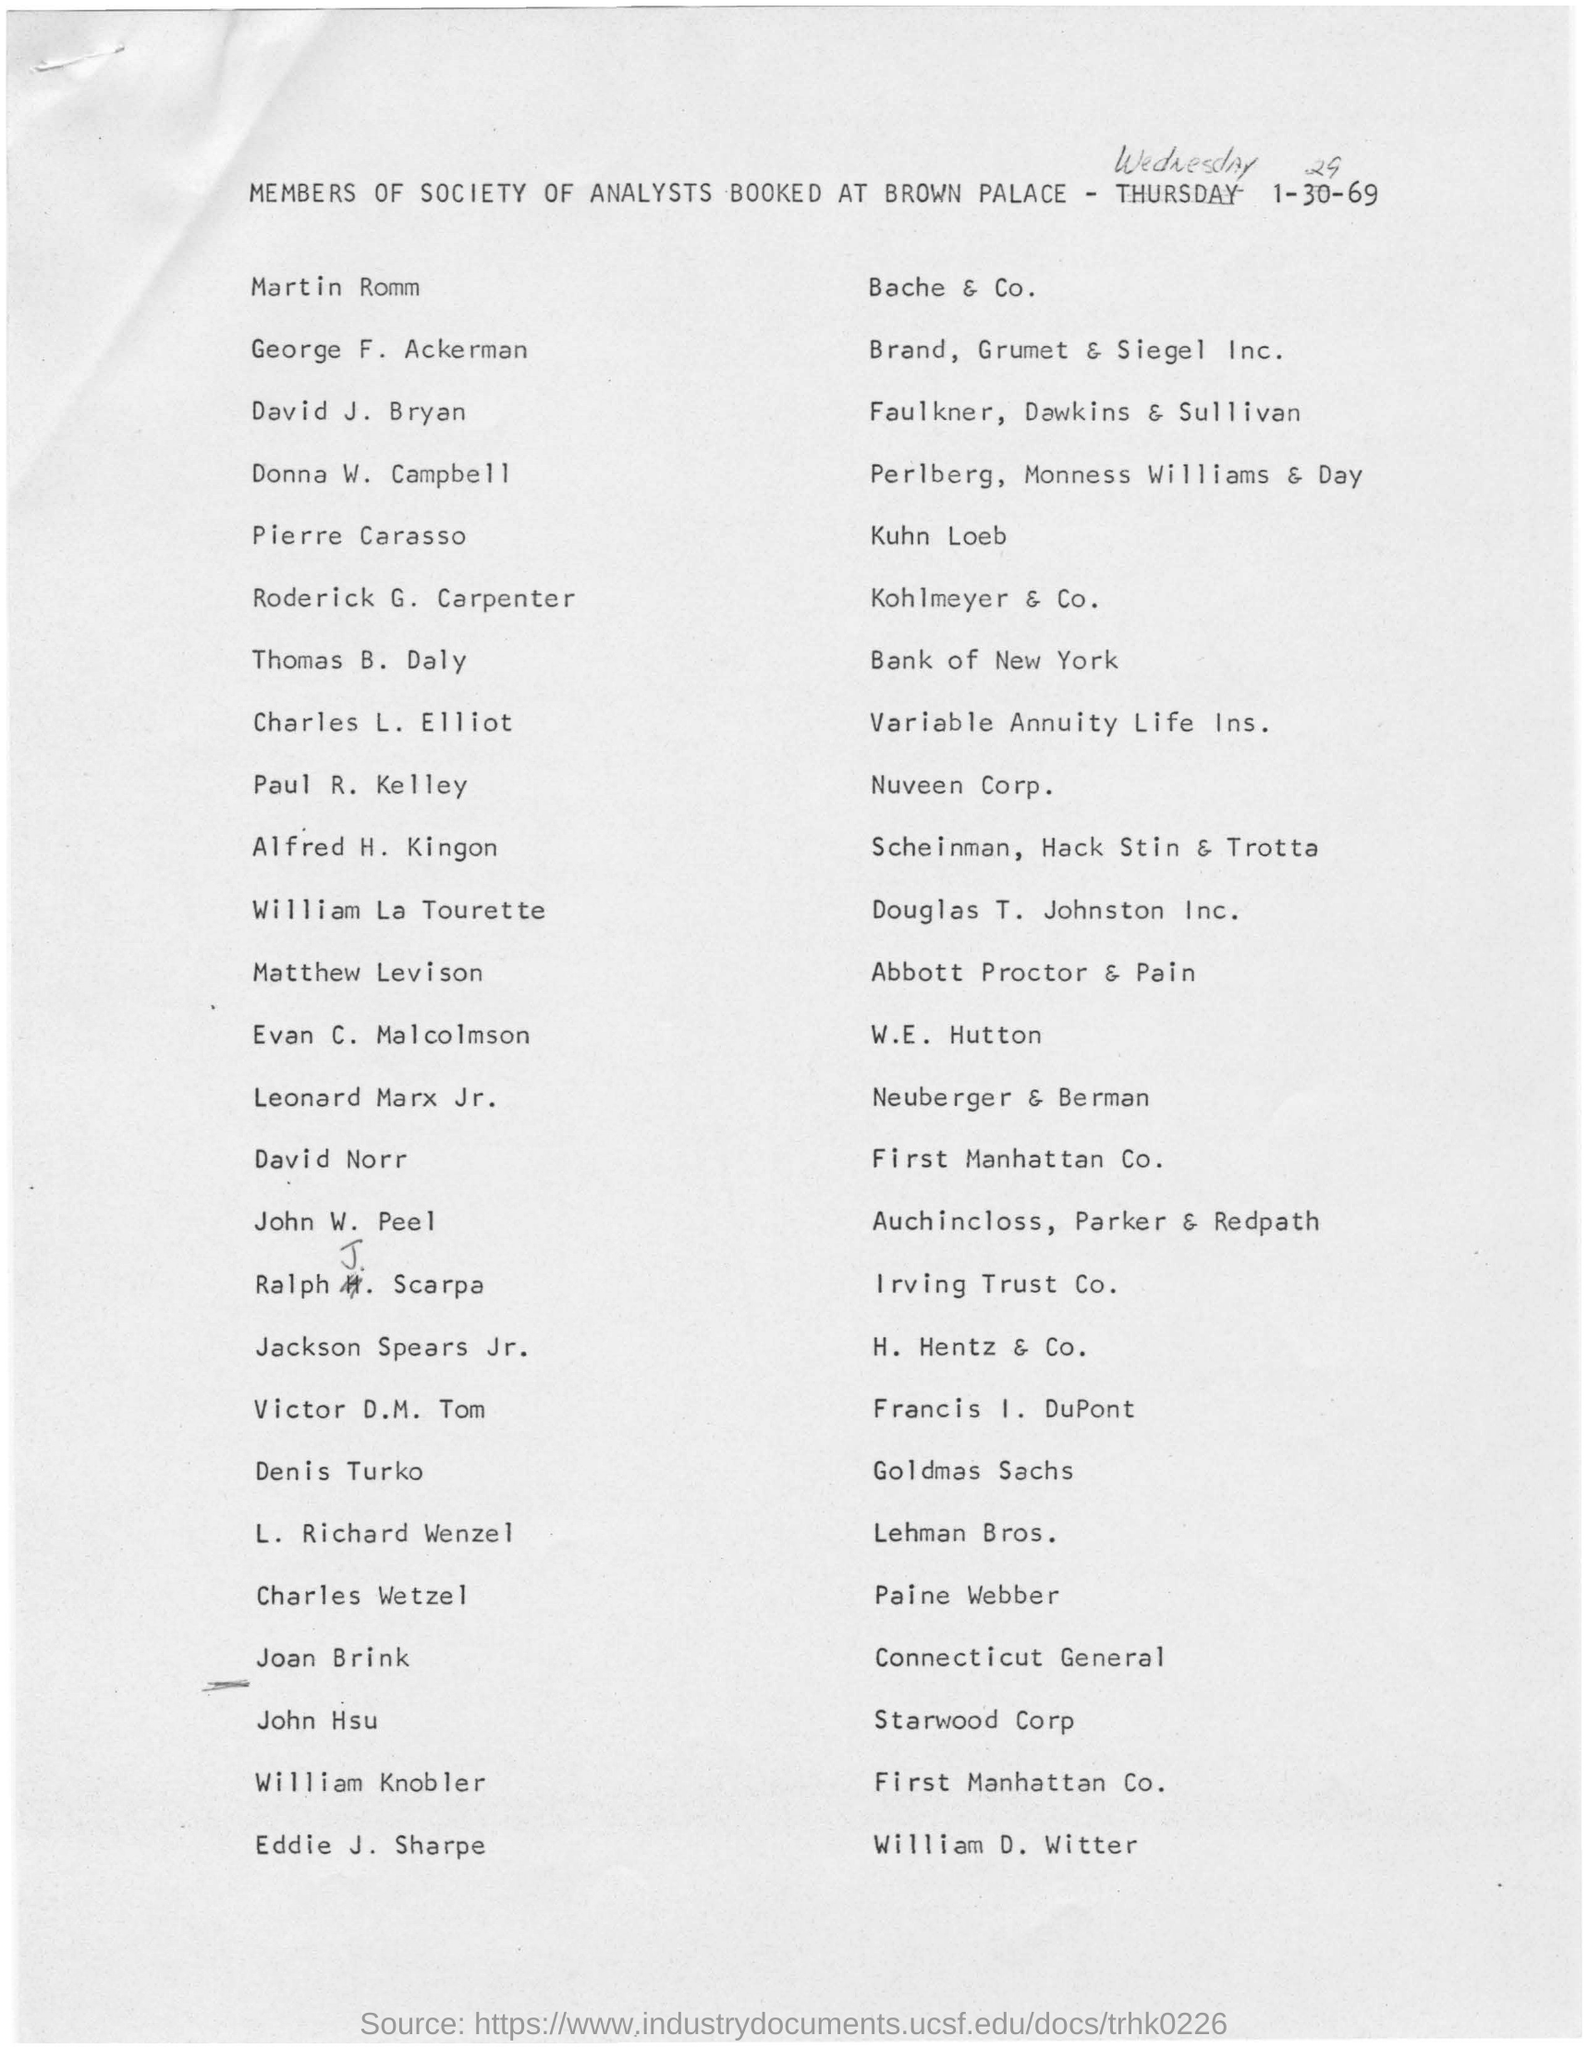Which society does the members belong to?
Give a very brief answer. MEMBERS OF SOCIETY OF ANALYSTS AT BROWN PALACE. 